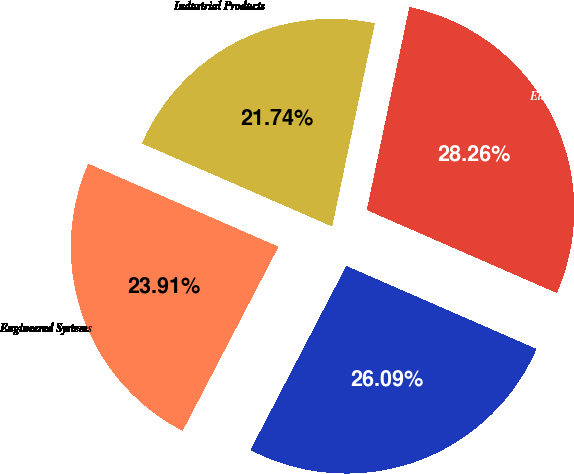Convert chart to OTSL. <chart><loc_0><loc_0><loc_500><loc_500><pie_chart><fcel>Industrial Products<fcel>Engineered Systems<fcel>Fluid Management<fcel>Electronic Technologies<nl><fcel>21.74%<fcel>23.91%<fcel>26.09%<fcel>28.26%<nl></chart> 